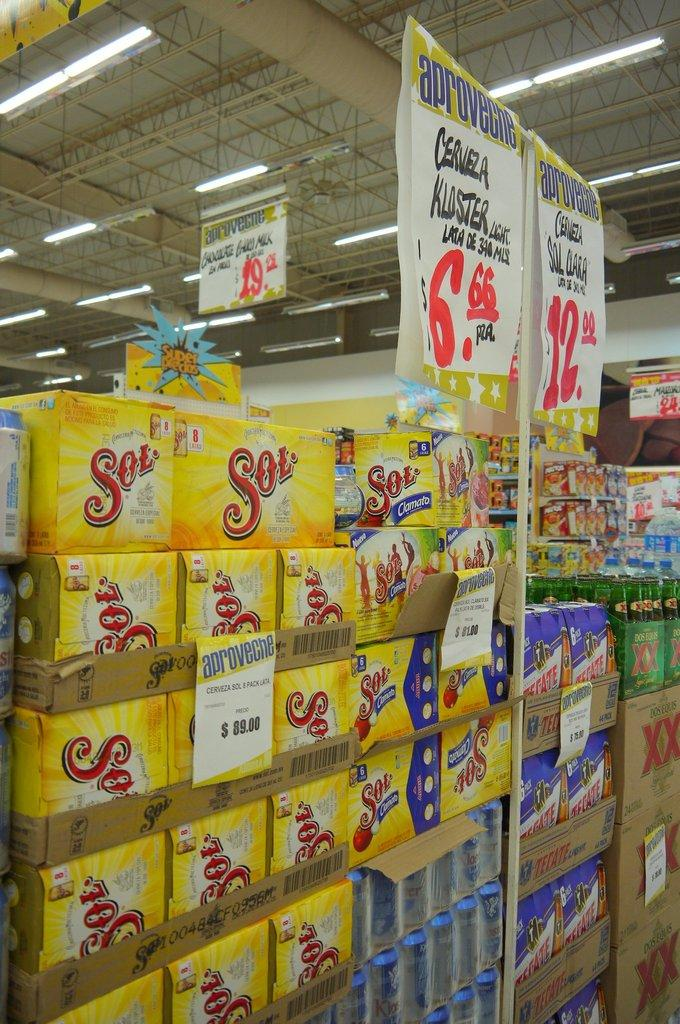Provide a one-sentence caption for the provided image. Several yellow boxes of Sol are stacked on top of each other. 